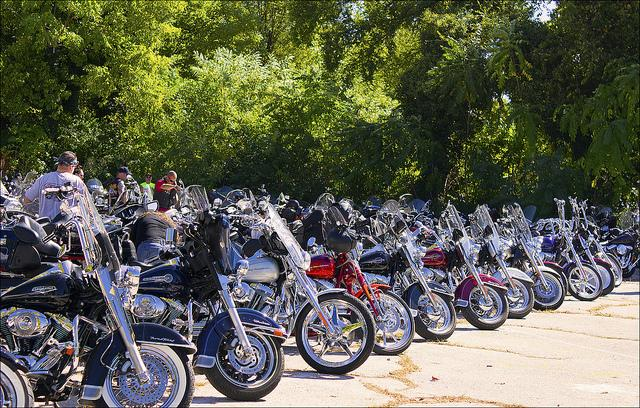Which direction are all the front wheels facing? Please explain your reasoning. left. They are all facing to the left. 